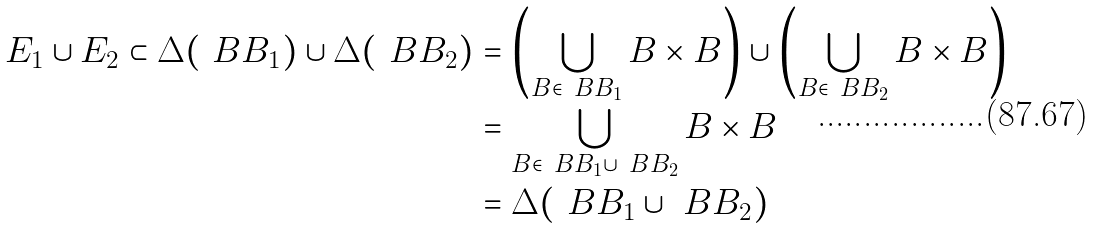<formula> <loc_0><loc_0><loc_500><loc_500>E _ { 1 } \cup E _ { 2 } \subset \Delta ( \ B B _ { 1 } ) \cup \Delta ( \ B B _ { 2 } ) & = \left ( \bigcup _ { B \in \ B B _ { 1 } } B \times B \right ) \cup \left ( \bigcup _ { B \in \ B B _ { 2 } } B \times B \right ) \\ & = \bigcup _ { B \in \ B B _ { 1 } \cup \ B B _ { 2 } } B \times B \\ & = \Delta ( \ B B _ { 1 } \cup \ B B _ { 2 } )</formula> 